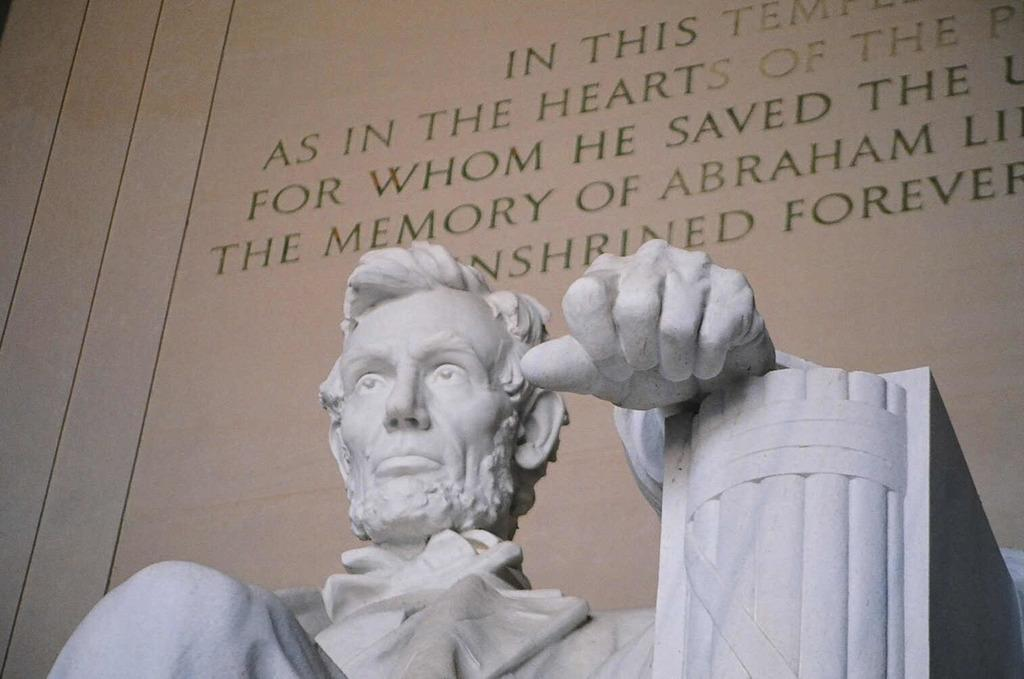What is the main subject of the image? There is a sculpture in the image. What can be seen in the background of the image? There is a wall in the background of the image. Is there any text visible in the image? Yes, text is written on the wall. What type of list can be seen on the sofa in the image? There is no sofa or list present in the image; it features a sculpture and a wall with text. 